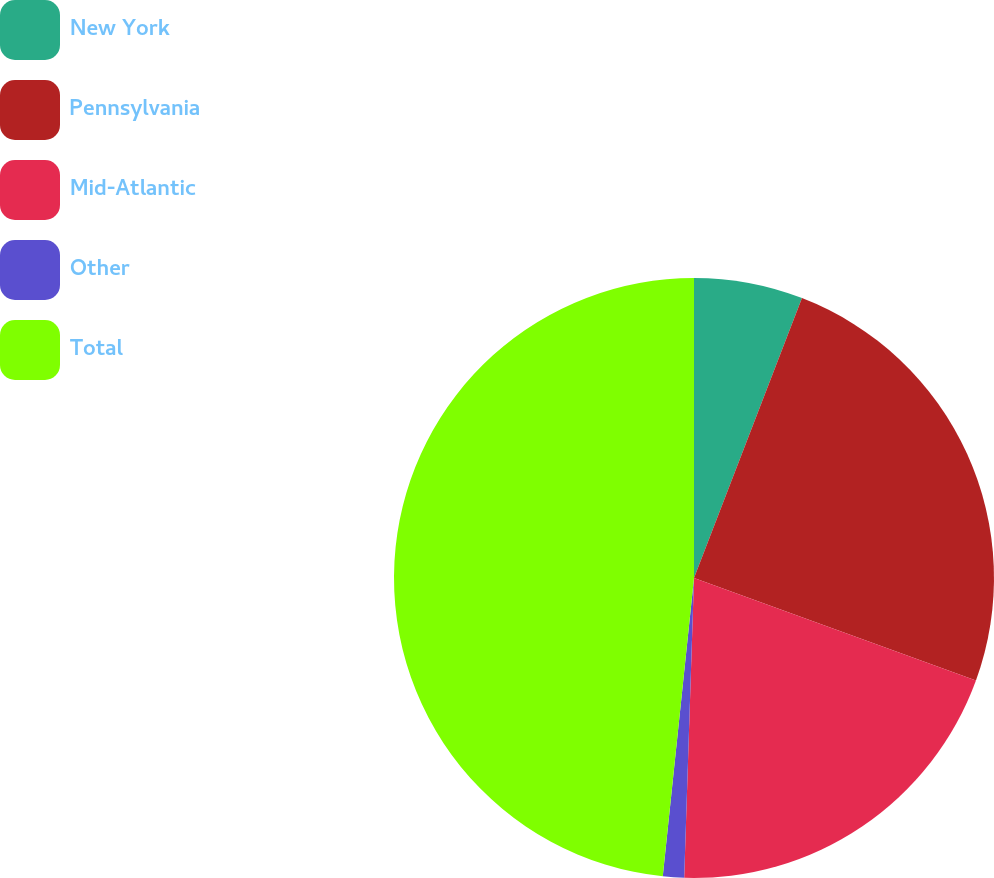Convert chart to OTSL. <chart><loc_0><loc_0><loc_500><loc_500><pie_chart><fcel>New York<fcel>Pennsylvania<fcel>Mid-Atlantic<fcel>Other<fcel>Total<nl><fcel>5.86%<fcel>24.69%<fcel>19.97%<fcel>1.14%<fcel>48.34%<nl></chart> 